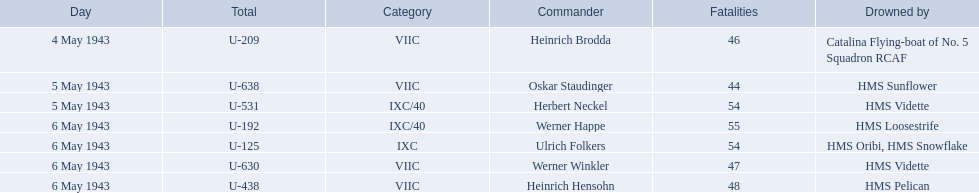Who are all of the captains? Heinrich Brodda, Oskar Staudinger, Herbert Neckel, Werner Happe, Ulrich Folkers, Werner Winkler, Heinrich Hensohn. Help me parse the entirety of this table. {'header': ['Day', 'Total', 'Category', 'Commander', 'Fatalities', 'Drowned by'], 'rows': [['4 May 1943', 'U-209', 'VIIC', 'Heinrich Brodda', '46', 'Catalina Flying-boat of No. 5 Squadron RCAF'], ['5 May 1943', 'U-638', 'VIIC', 'Oskar Staudinger', '44', 'HMS Sunflower'], ['5 May 1943', 'U-531', 'IXC/40', 'Herbert Neckel', '54', 'HMS Vidette'], ['6 May 1943', 'U-192', 'IXC/40', 'Werner Happe', '55', 'HMS Loosestrife'], ['6 May 1943', 'U-125', 'IXC', 'Ulrich Folkers', '54', 'HMS Oribi, HMS Snowflake'], ['6 May 1943', 'U-630', 'VIIC', 'Werner Winkler', '47', 'HMS Vidette'], ['6 May 1943', 'U-438', 'VIIC', 'Heinrich Hensohn', '48', 'HMS Pelican']]} What sunk each of the captains? Catalina Flying-boat of No. 5 Squadron RCAF, HMS Sunflower, HMS Vidette, HMS Loosestrife, HMS Oribi, HMS Snowflake, HMS Vidette, HMS Pelican. Which was sunk by the hms pelican? Heinrich Hensohn. 